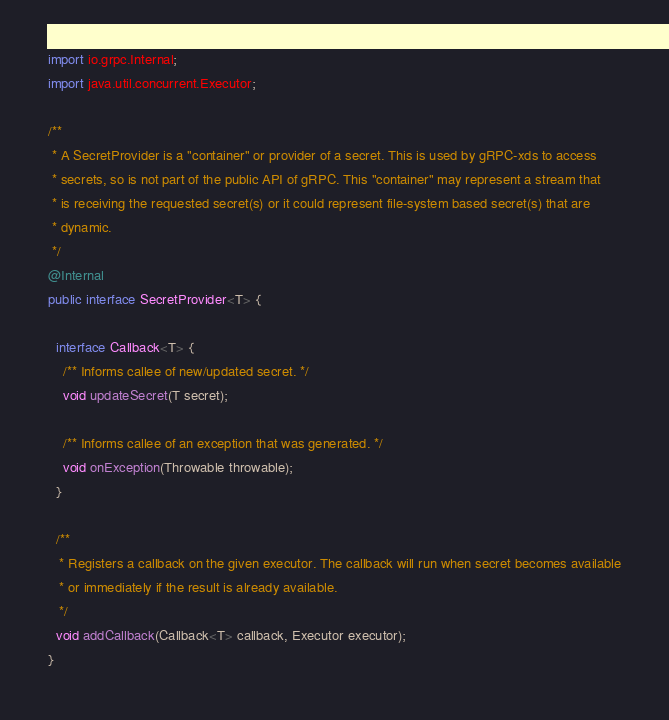Convert code to text. <code><loc_0><loc_0><loc_500><loc_500><_Java_>
import io.grpc.Internal;
import java.util.concurrent.Executor;

/**
 * A SecretProvider is a "container" or provider of a secret. This is used by gRPC-xds to access
 * secrets, so is not part of the public API of gRPC. This "container" may represent a stream that
 * is receiving the requested secret(s) or it could represent file-system based secret(s) that are
 * dynamic.
 */
@Internal
public interface SecretProvider<T> {

  interface Callback<T> {
    /** Informs callee of new/updated secret. */
    void updateSecret(T secret);

    /** Informs callee of an exception that was generated. */
    void onException(Throwable throwable);
  }

  /**
   * Registers a callback on the given executor. The callback will run when secret becomes available
   * or immediately if the result is already available.
   */
  void addCallback(Callback<T> callback, Executor executor);
}
</code> 